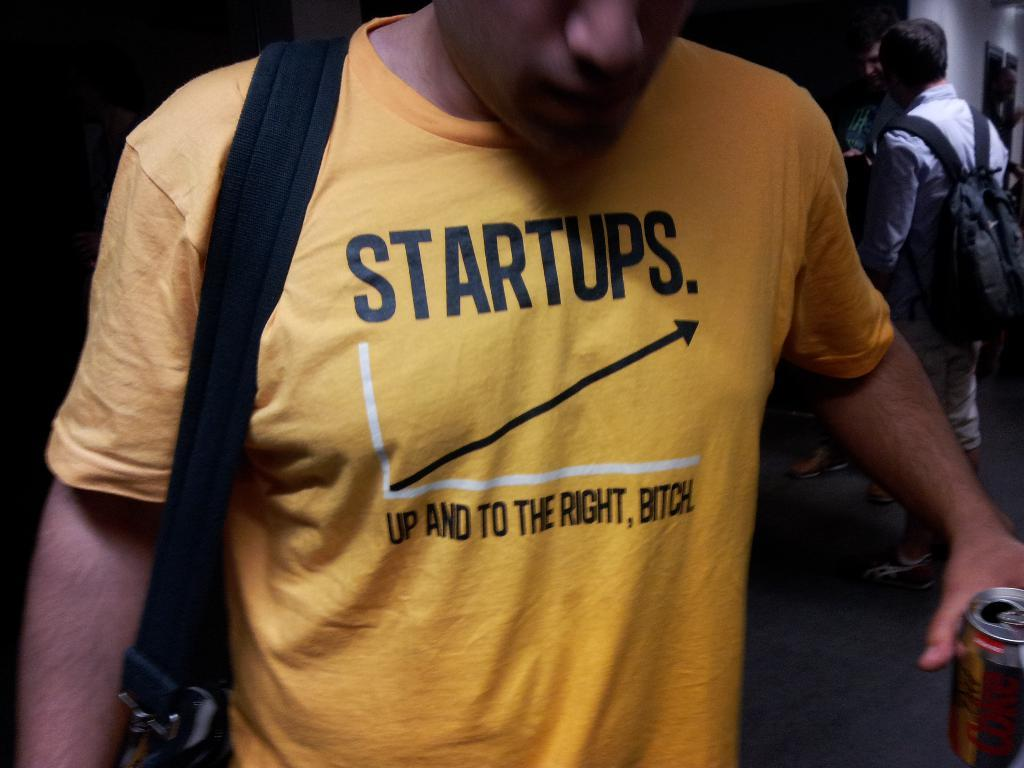<image>
Render a clear and concise summary of the photo. A person has a yellow shirt on with the word startups on the front. 